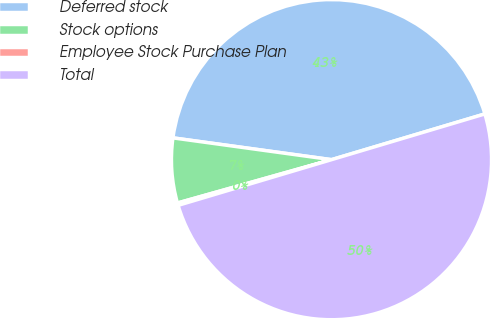Convert chart to OTSL. <chart><loc_0><loc_0><loc_500><loc_500><pie_chart><fcel>Deferred stock<fcel>Stock options<fcel>Employee Stock Purchase Plan<fcel>Total<nl><fcel>43.21%<fcel>6.54%<fcel>0.24%<fcel>50.0%<nl></chart> 